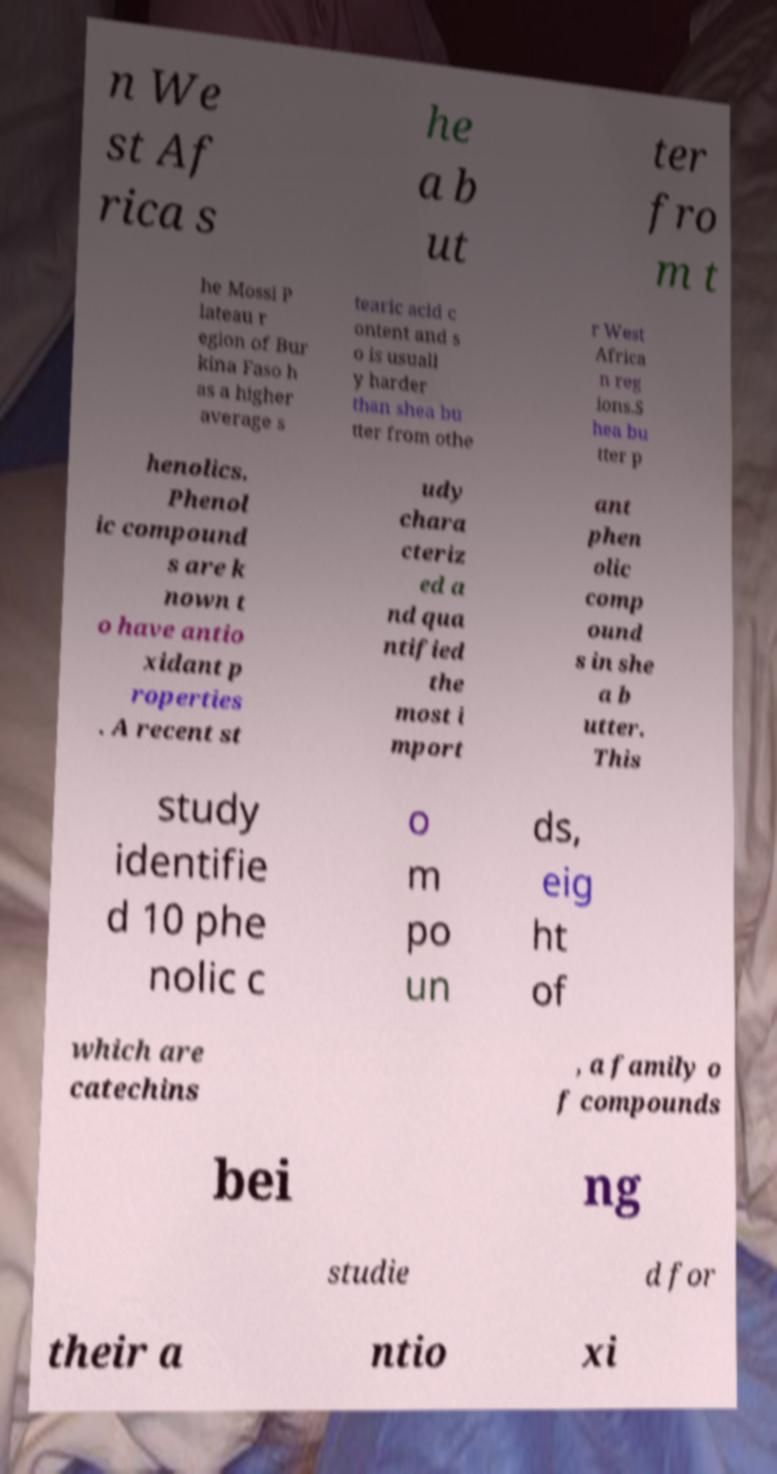Can you accurately transcribe the text from the provided image for me? n We st Af rica s he a b ut ter fro m t he Mossi P lateau r egion of Bur kina Faso h as a higher average s tearic acid c ontent and s o is usuall y harder than shea bu tter from othe r West Africa n reg ions.S hea bu tter p henolics. Phenol ic compound s are k nown t o have antio xidant p roperties . A recent st udy chara cteriz ed a nd qua ntified the most i mport ant phen olic comp ound s in she a b utter. This study identifie d 10 phe nolic c o m po un ds, eig ht of which are catechins , a family o f compounds bei ng studie d for their a ntio xi 